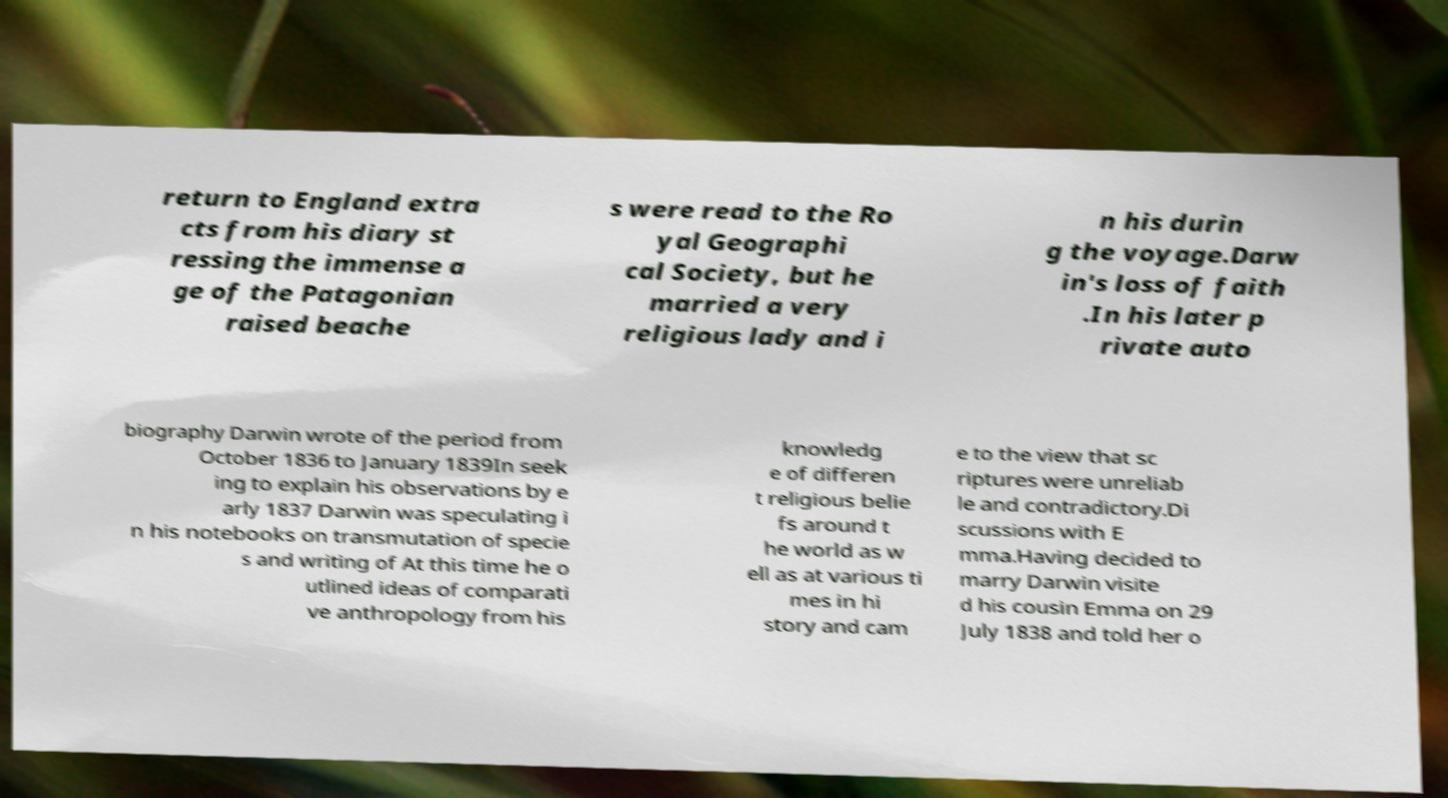Please read and relay the text visible in this image. What does it say? return to England extra cts from his diary st ressing the immense a ge of the Patagonian raised beache s were read to the Ro yal Geographi cal Society, but he married a very religious lady and i n his durin g the voyage.Darw in's loss of faith .In his later p rivate auto biography Darwin wrote of the period from October 1836 to January 1839In seek ing to explain his observations by e arly 1837 Darwin was speculating i n his notebooks on transmutation of specie s and writing of At this time he o utlined ideas of comparati ve anthropology from his knowledg e of differen t religious belie fs around t he world as w ell as at various ti mes in hi story and cam e to the view that sc riptures were unreliab le and contradictory.Di scussions with E mma.Having decided to marry Darwin visite d his cousin Emma on 29 July 1838 and told her o 